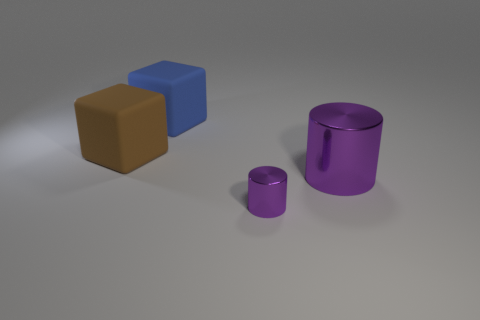What shape is the shiny thing in front of the metallic thing to the right of the purple cylinder in front of the large purple thing?
Offer a very short reply. Cylinder. Are there fewer rubber objects that are left of the blue cube than large metal objects to the right of the big metallic thing?
Provide a short and direct response. No. Is the shape of the purple thing left of the big metal thing the same as the big object that is right of the large blue matte object?
Offer a terse response. Yes. What shape is the matte object in front of the big rubber cube that is behind the big brown rubber thing?
Offer a very short reply. Cube. The other metallic object that is the same color as the small thing is what size?
Offer a terse response. Large. Is there another large cylinder that has the same material as the big purple cylinder?
Offer a very short reply. No. There is a thing that is left of the blue rubber thing; what is it made of?
Your response must be concise. Rubber. What material is the small purple object?
Give a very brief answer. Metal. Do the purple cylinder that is behind the small purple cylinder and the small purple object have the same material?
Provide a succinct answer. Yes. Are there fewer rubber objects that are on the right side of the small object than big shiny cylinders?
Give a very brief answer. Yes. 